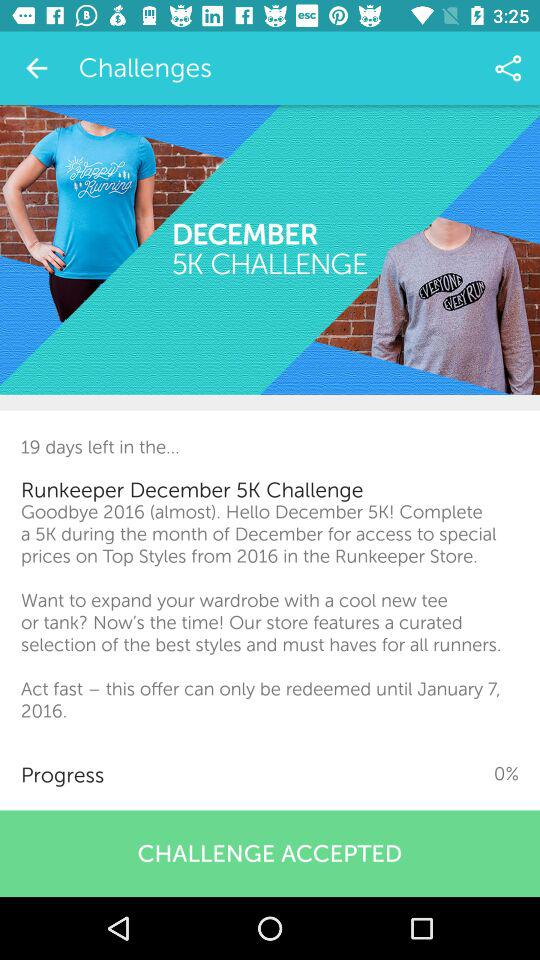How many days are left for the "Runkeeper December 5K Challenge"? There are 19 days left for the "Runkeeper December 5K Challenge". 